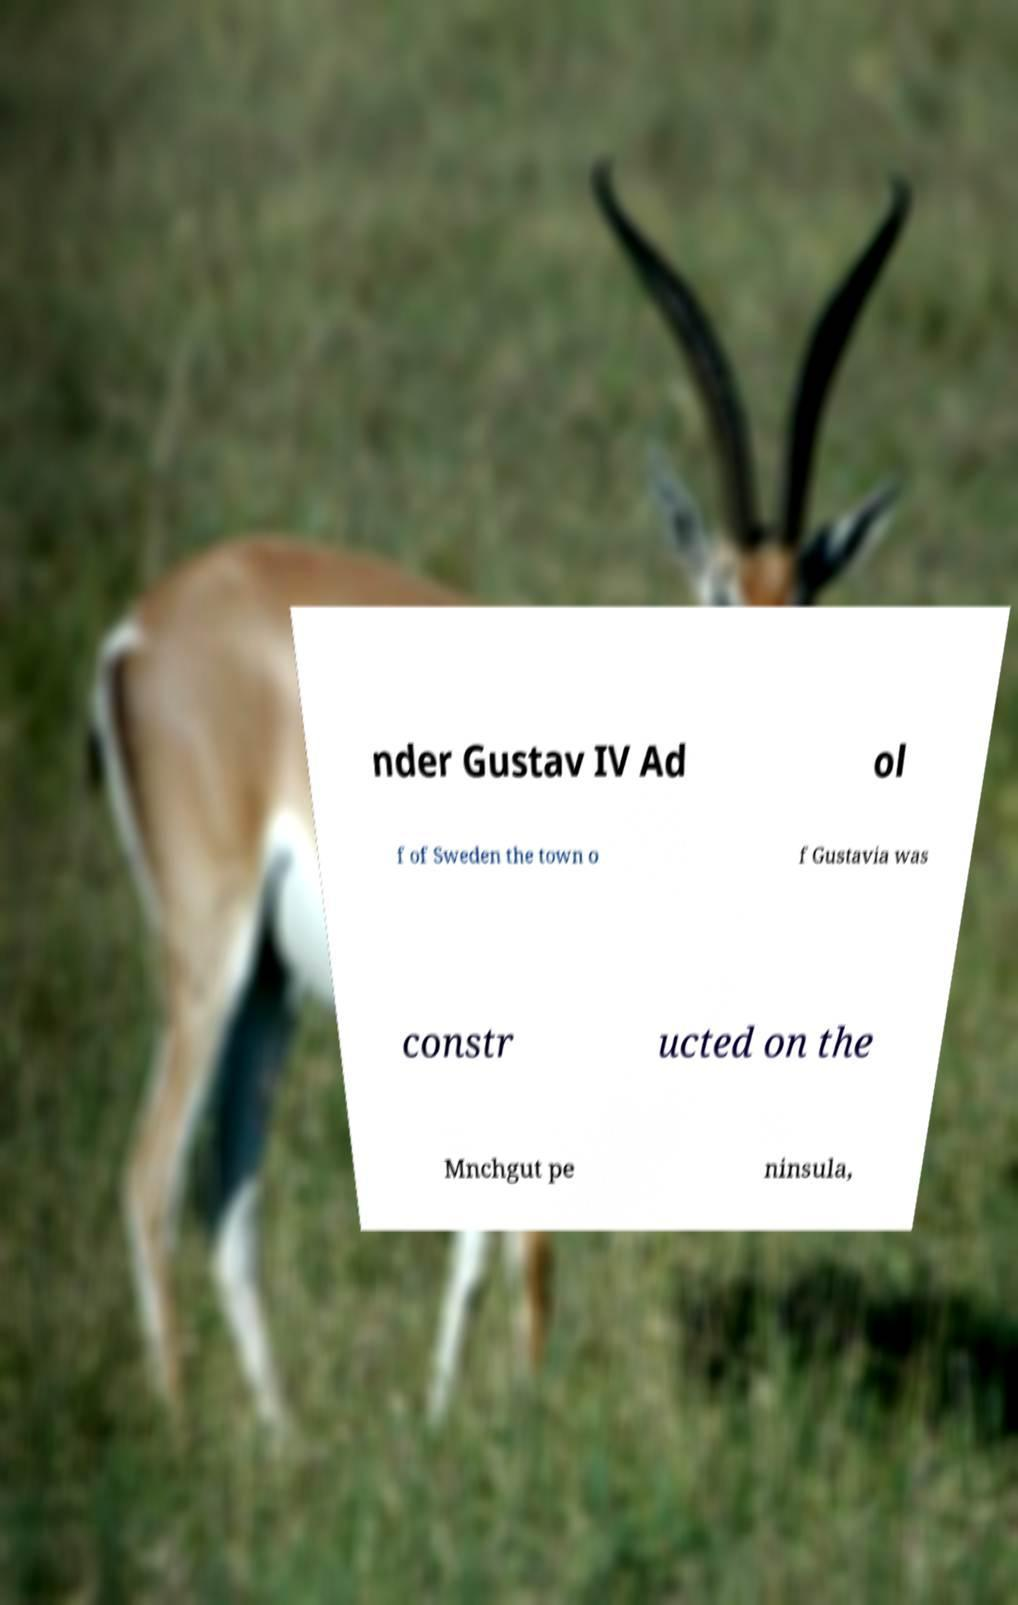For documentation purposes, I need the text within this image transcribed. Could you provide that? nder Gustav IV Ad ol f of Sweden the town o f Gustavia was constr ucted on the Mnchgut pe ninsula, 